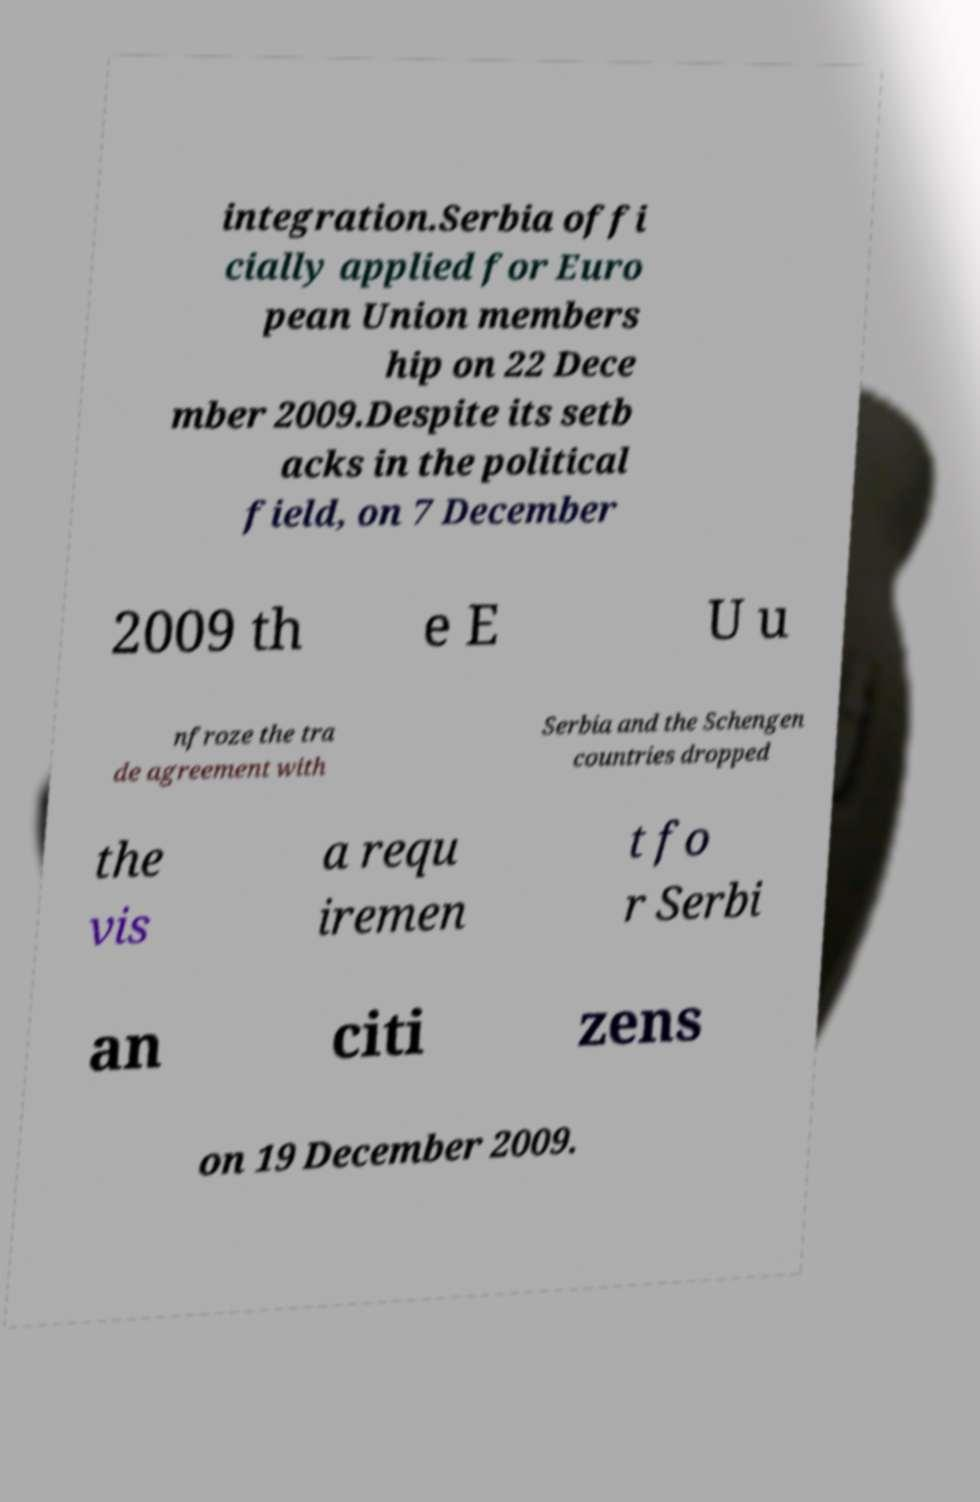Could you assist in decoding the text presented in this image and type it out clearly? integration.Serbia offi cially applied for Euro pean Union members hip on 22 Dece mber 2009.Despite its setb acks in the political field, on 7 December 2009 th e E U u nfroze the tra de agreement with Serbia and the Schengen countries dropped the vis a requ iremen t fo r Serbi an citi zens on 19 December 2009. 